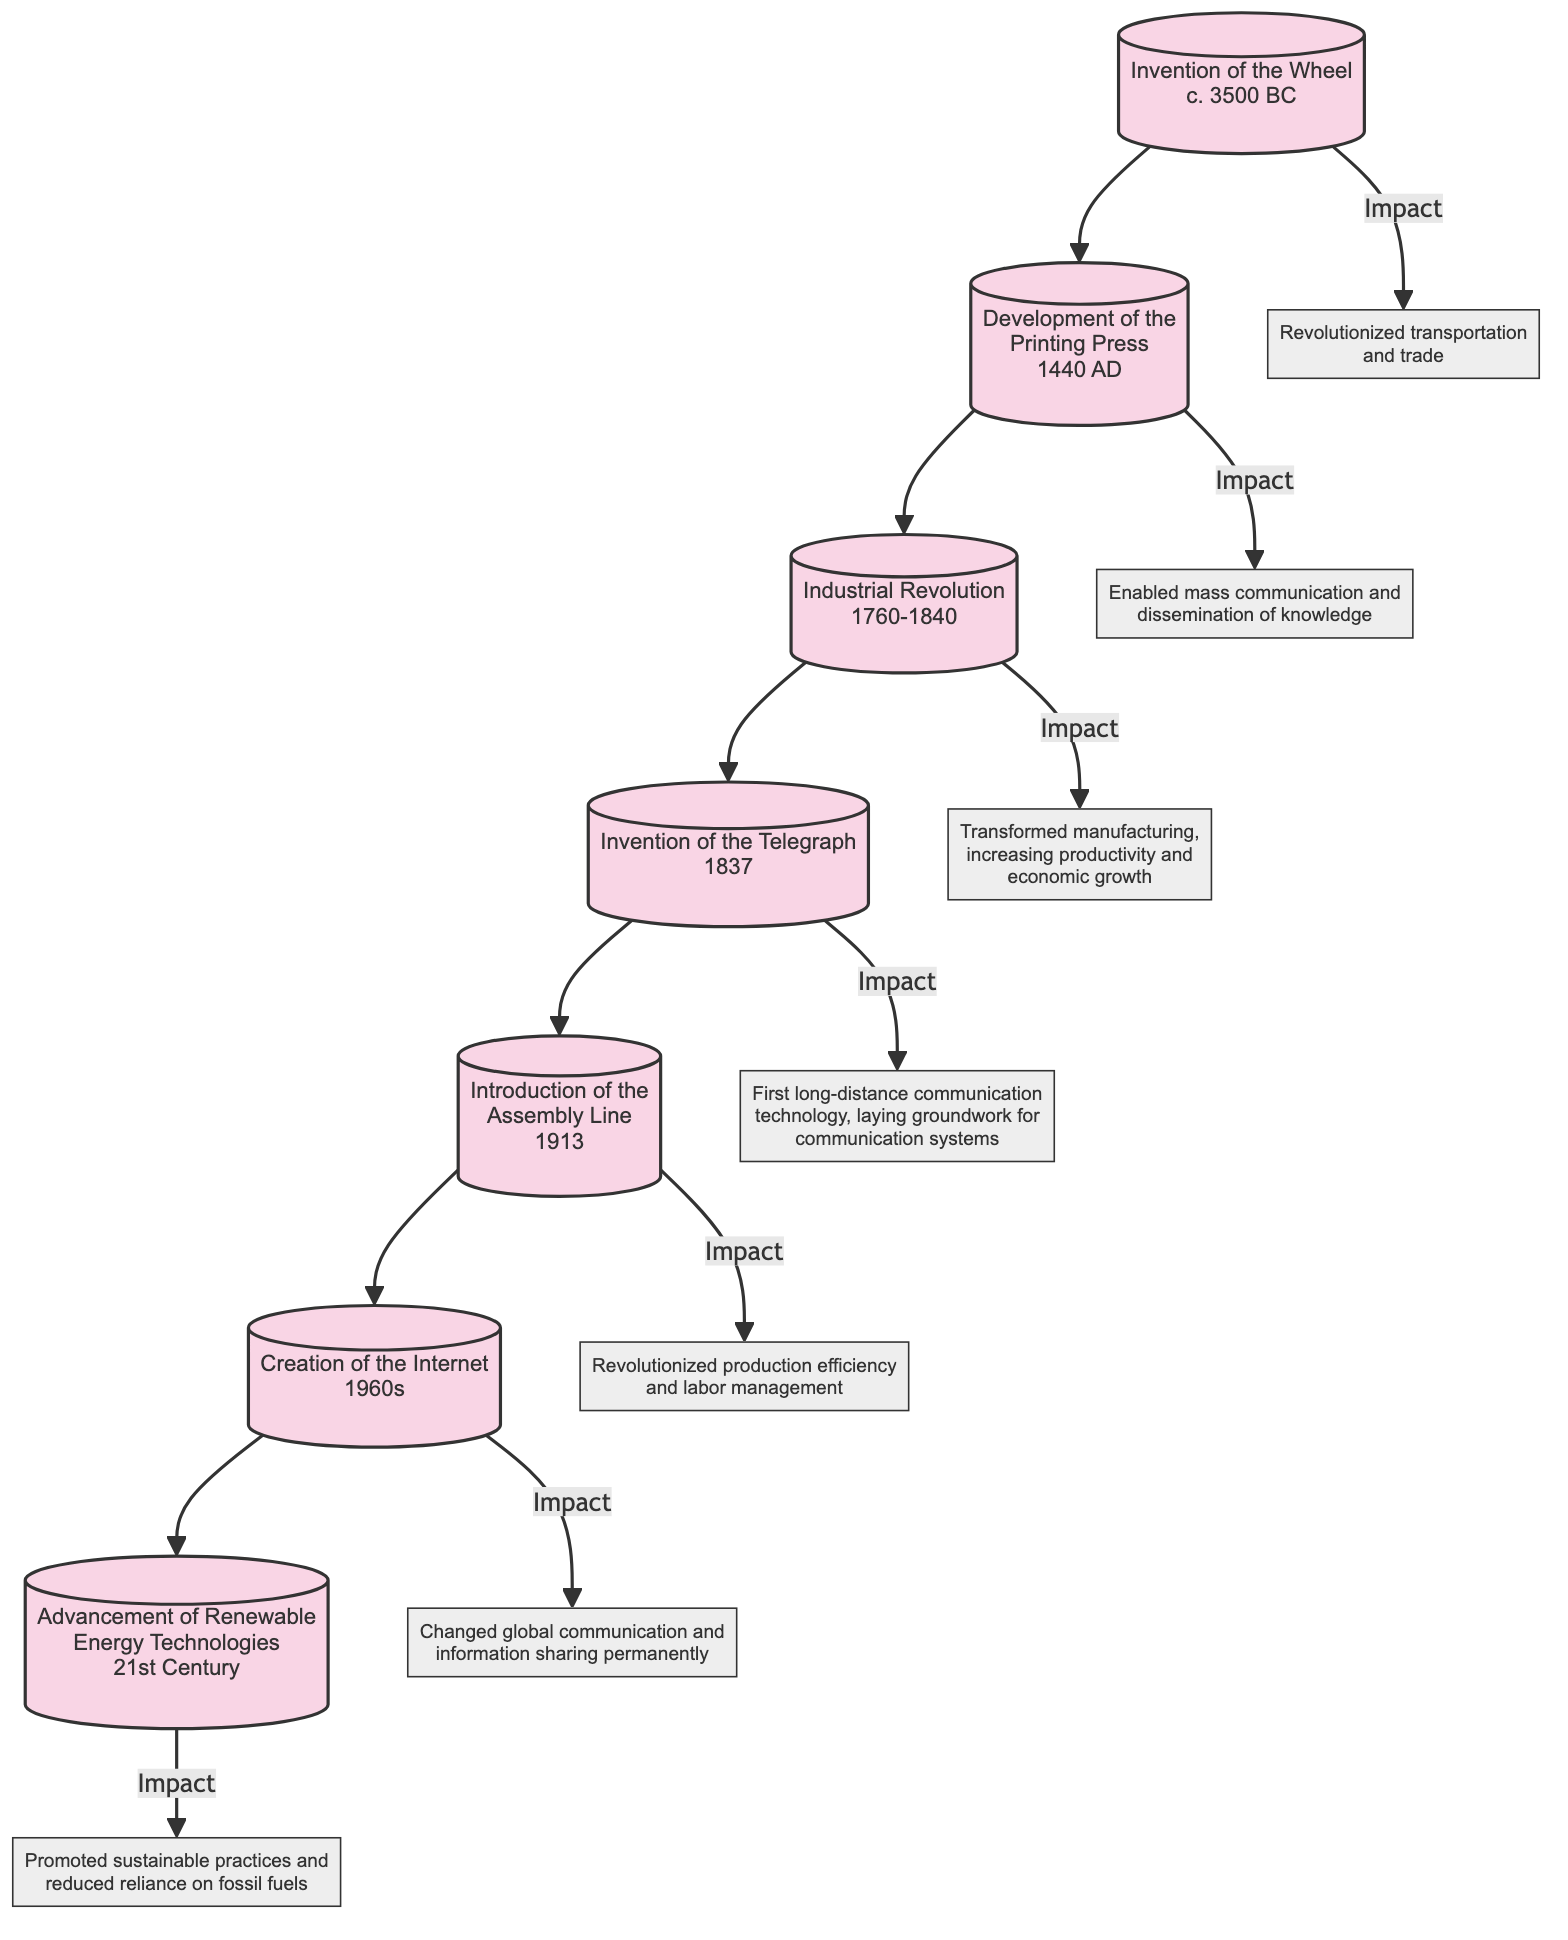What is the first event listed in the flow chart? The flow chart starts with the "Invention of the Wheel," which is the topmost node in the diagram.
Answer: Invention of the Wheel Which event occurred in 1913? The flow chart shows that the "Introduction of the Assembly Line" is the event that occurred in 1913, indicated next to the date.
Answer: Introduction of the Assembly Line How many events are shown in total in the diagram? The diagram lists seven events. You can count each event node (Invention of the Wheel, Development of the Printing Press, etc.) to find the total.
Answer: 7 What impact is associated with the Development of the Printing Press? The flow chart specifies that the impact of the Development of the Printing Press is that it enabled mass communication and dissemination of knowledge.
Answer: Enabled mass communication and dissemination of knowledge Which event shows an advancement in communication technology in the 19th century? "Invention of the Telegraph" is the event from 1837 that represents an advancement in communication technology during the 19th century.
Answer: Invention of the Telegraph How does the timeline progress in the flow chart? The flow chart progresses chronologically from the top to the bottom, with events ordered sequentially by their dates, starting from 3500 BC to the 21st Century.
Answer: Chronologically from top to bottom What is the last event listed in the flow chart? The last event mentioned in the flow chart is "Advancement of Renewable Energy Technologies," which is situated at the bottom of the diagram.
Answer: Advancement of Renewable Energy Technologies Which event revolutionized transportation and trade? According to the flow chart, the "Invention of the Wheel" is linked to the impact that revolutionized transportation and trade.
Answer: Invention of the Wheel What did the Industrial Revolution transform? The diagram connects the Industrial Revolution to the transformation of manufacturing, highlighting increased productivity and economic growth as its impact.
Answer: Manufacturing, increasing productivity and economic growth 